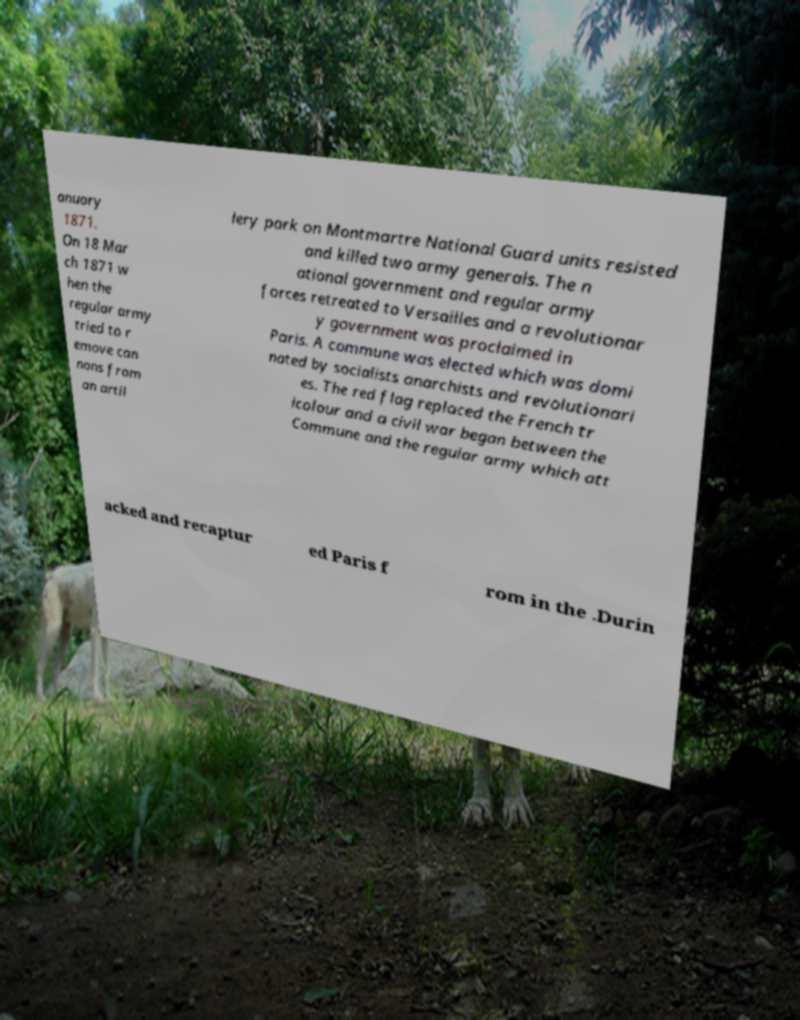Could you extract and type out the text from this image? anuary 1871. On 18 Mar ch 1871 w hen the regular army tried to r emove can nons from an artil lery park on Montmartre National Guard units resisted and killed two army generals. The n ational government and regular army forces retreated to Versailles and a revolutionar y government was proclaimed in Paris. A commune was elected which was domi nated by socialists anarchists and revolutionari es. The red flag replaced the French tr icolour and a civil war began between the Commune and the regular army which att acked and recaptur ed Paris f rom in the .Durin 